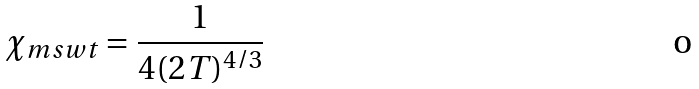<formula> <loc_0><loc_0><loc_500><loc_500>\chi _ { m s w t } = \frac { 1 } { 4 ( 2 T ) ^ { 4 / 3 } }</formula> 